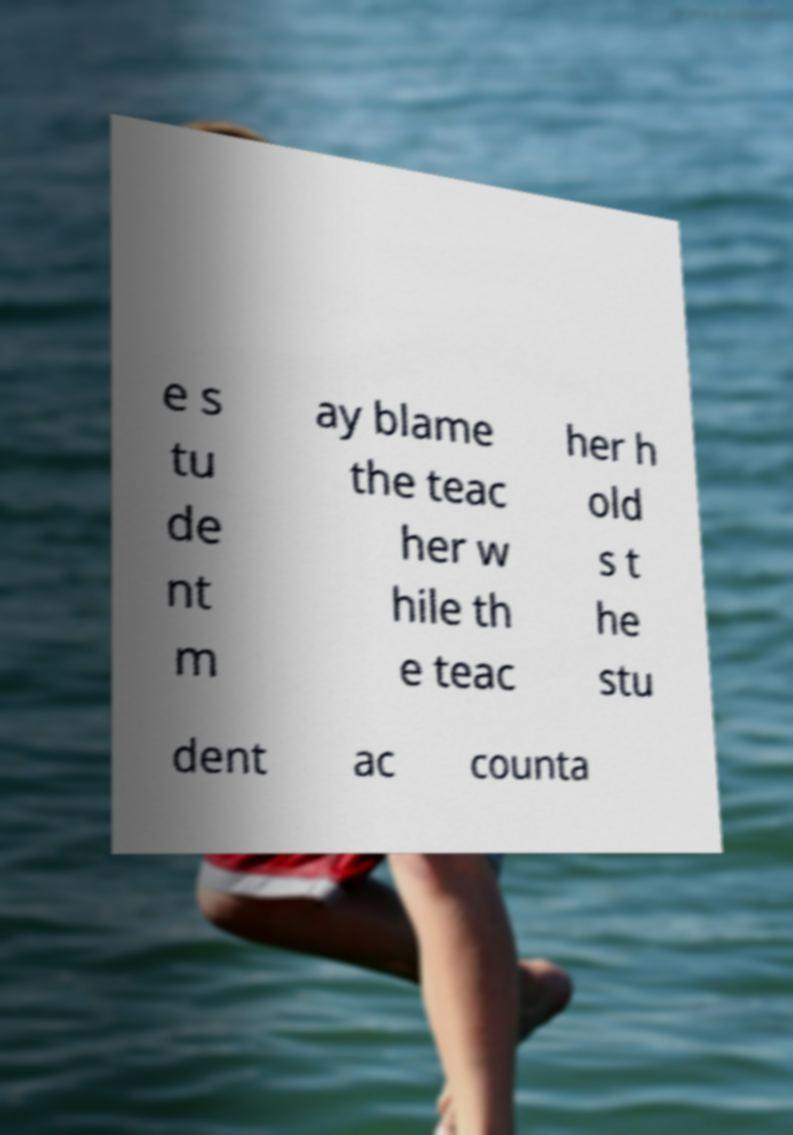Can you read and provide the text displayed in the image?This photo seems to have some interesting text. Can you extract and type it out for me? e s tu de nt m ay blame the teac her w hile th e teac her h old s t he stu dent ac counta 